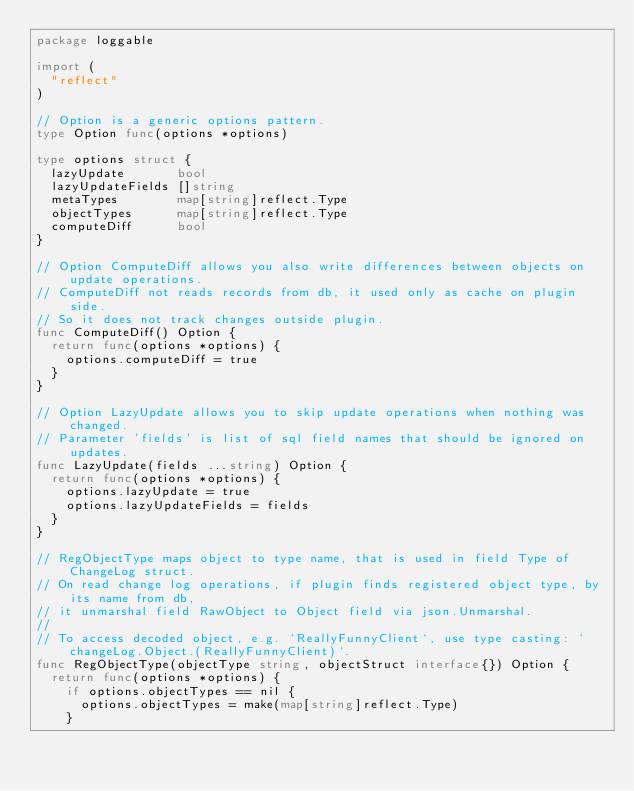Convert code to text. <code><loc_0><loc_0><loc_500><loc_500><_Go_>package loggable

import (
	"reflect"
)

// Option is a generic options pattern.
type Option func(options *options)

type options struct {
	lazyUpdate       bool
	lazyUpdateFields []string
	metaTypes        map[string]reflect.Type
	objectTypes      map[string]reflect.Type
	computeDiff      bool
}

// Option ComputeDiff allows you also write differences between objects on update operations.
// ComputeDiff not reads records from db, it used only as cache on plugin side.
// So it does not track changes outside plugin.
func ComputeDiff() Option {
	return func(options *options) {
		options.computeDiff = true
	}
}

// Option LazyUpdate allows you to skip update operations when nothing was changed.
// Parameter 'fields' is list of sql field names that should be ignored on updates.
func LazyUpdate(fields ...string) Option {
	return func(options *options) {
		options.lazyUpdate = true
		options.lazyUpdateFields = fields
	}
}

// RegObjectType maps object to type name, that is used in field Type of ChangeLog struct.
// On read change log operations, if plugin finds registered object type, by its name from db,
// it unmarshal field RawObject to Object field via json.Unmarshal.
//
// To access decoded object, e.g. `ReallyFunnyClient`, use type casting: `changeLog.Object.(ReallyFunnyClient)`.
func RegObjectType(objectType string, objectStruct interface{}) Option {
	return func(options *options) {
		if options.objectTypes == nil {
			options.objectTypes = make(map[string]reflect.Type)
		}</code> 